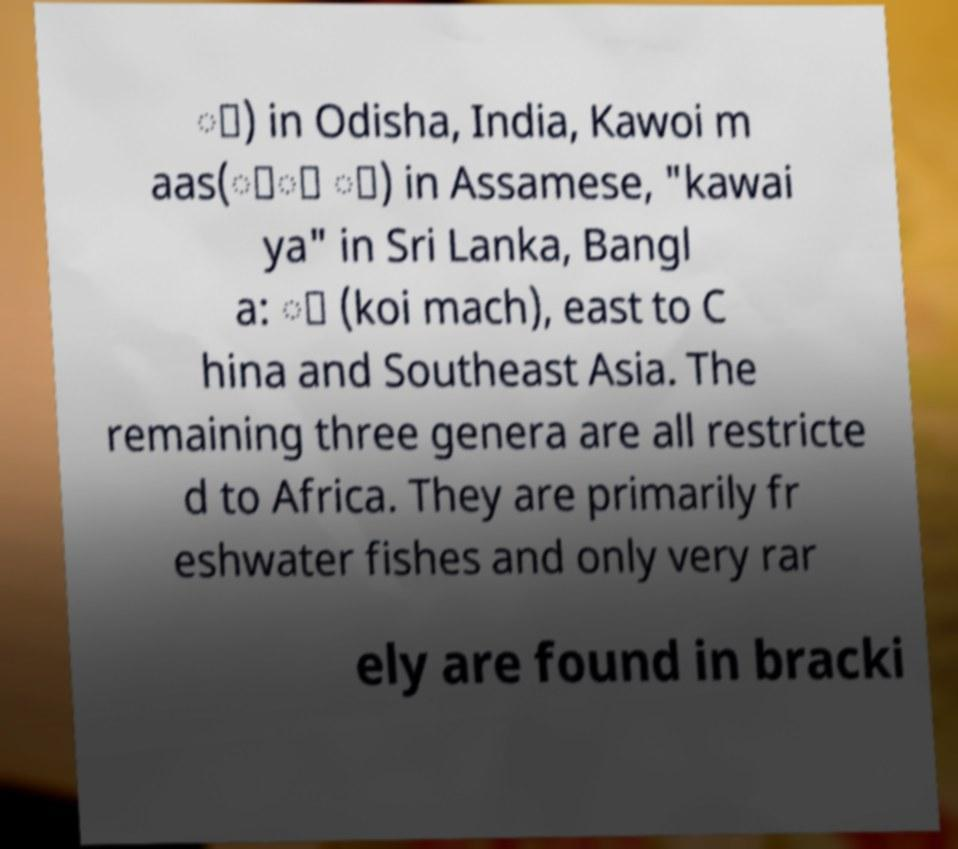Can you accurately transcribe the text from the provided image for me? ା) in Odisha, India, Kawoi m aas(াৈ া) in Assamese, "kawai ya" in Sri Lanka, Bangl a: া (koi mach), east to C hina and Southeast Asia. The remaining three genera are all restricte d to Africa. They are primarily fr eshwater fishes and only very rar ely are found in bracki 